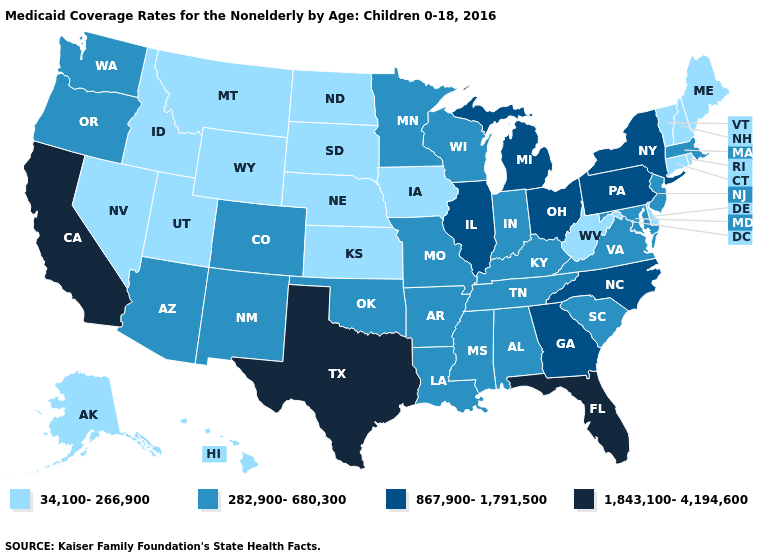Among the states that border Minnesota , which have the highest value?
Write a very short answer. Wisconsin. Does Oklahoma have the lowest value in the South?
Be succinct. No. Is the legend a continuous bar?
Concise answer only. No. Does the map have missing data?
Answer briefly. No. Does Oklahoma have the highest value in the USA?
Answer briefly. No. Name the states that have a value in the range 282,900-680,300?
Be succinct. Alabama, Arizona, Arkansas, Colorado, Indiana, Kentucky, Louisiana, Maryland, Massachusetts, Minnesota, Mississippi, Missouri, New Jersey, New Mexico, Oklahoma, Oregon, South Carolina, Tennessee, Virginia, Washington, Wisconsin. Does Michigan have the highest value in the USA?
Concise answer only. No. Name the states that have a value in the range 1,843,100-4,194,600?
Answer briefly. California, Florida, Texas. How many symbols are there in the legend?
Concise answer only. 4. Which states have the lowest value in the Northeast?
Be succinct. Connecticut, Maine, New Hampshire, Rhode Island, Vermont. Among the states that border New Hampshire , does Maine have the highest value?
Give a very brief answer. No. Does the first symbol in the legend represent the smallest category?
Answer briefly. Yes. Which states have the highest value in the USA?
Concise answer only. California, Florida, Texas. What is the value of Utah?
Write a very short answer. 34,100-266,900. Name the states that have a value in the range 282,900-680,300?
Concise answer only. Alabama, Arizona, Arkansas, Colorado, Indiana, Kentucky, Louisiana, Maryland, Massachusetts, Minnesota, Mississippi, Missouri, New Jersey, New Mexico, Oklahoma, Oregon, South Carolina, Tennessee, Virginia, Washington, Wisconsin. 